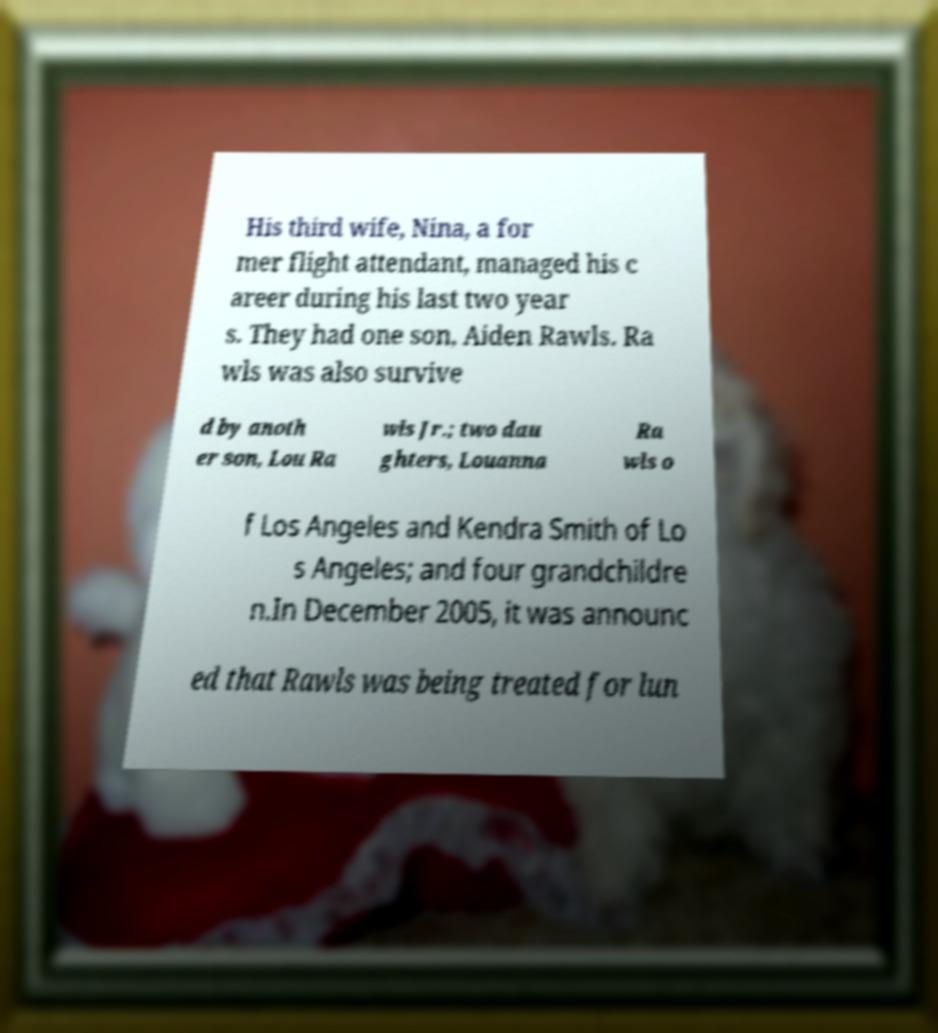Could you assist in decoding the text presented in this image and type it out clearly? His third wife, Nina, a for mer flight attendant, managed his c areer during his last two year s. They had one son, Aiden Rawls. Ra wls was also survive d by anoth er son, Lou Ra wls Jr.; two dau ghters, Louanna Ra wls o f Los Angeles and Kendra Smith of Lo s Angeles; and four grandchildre n.In December 2005, it was announc ed that Rawls was being treated for lun 